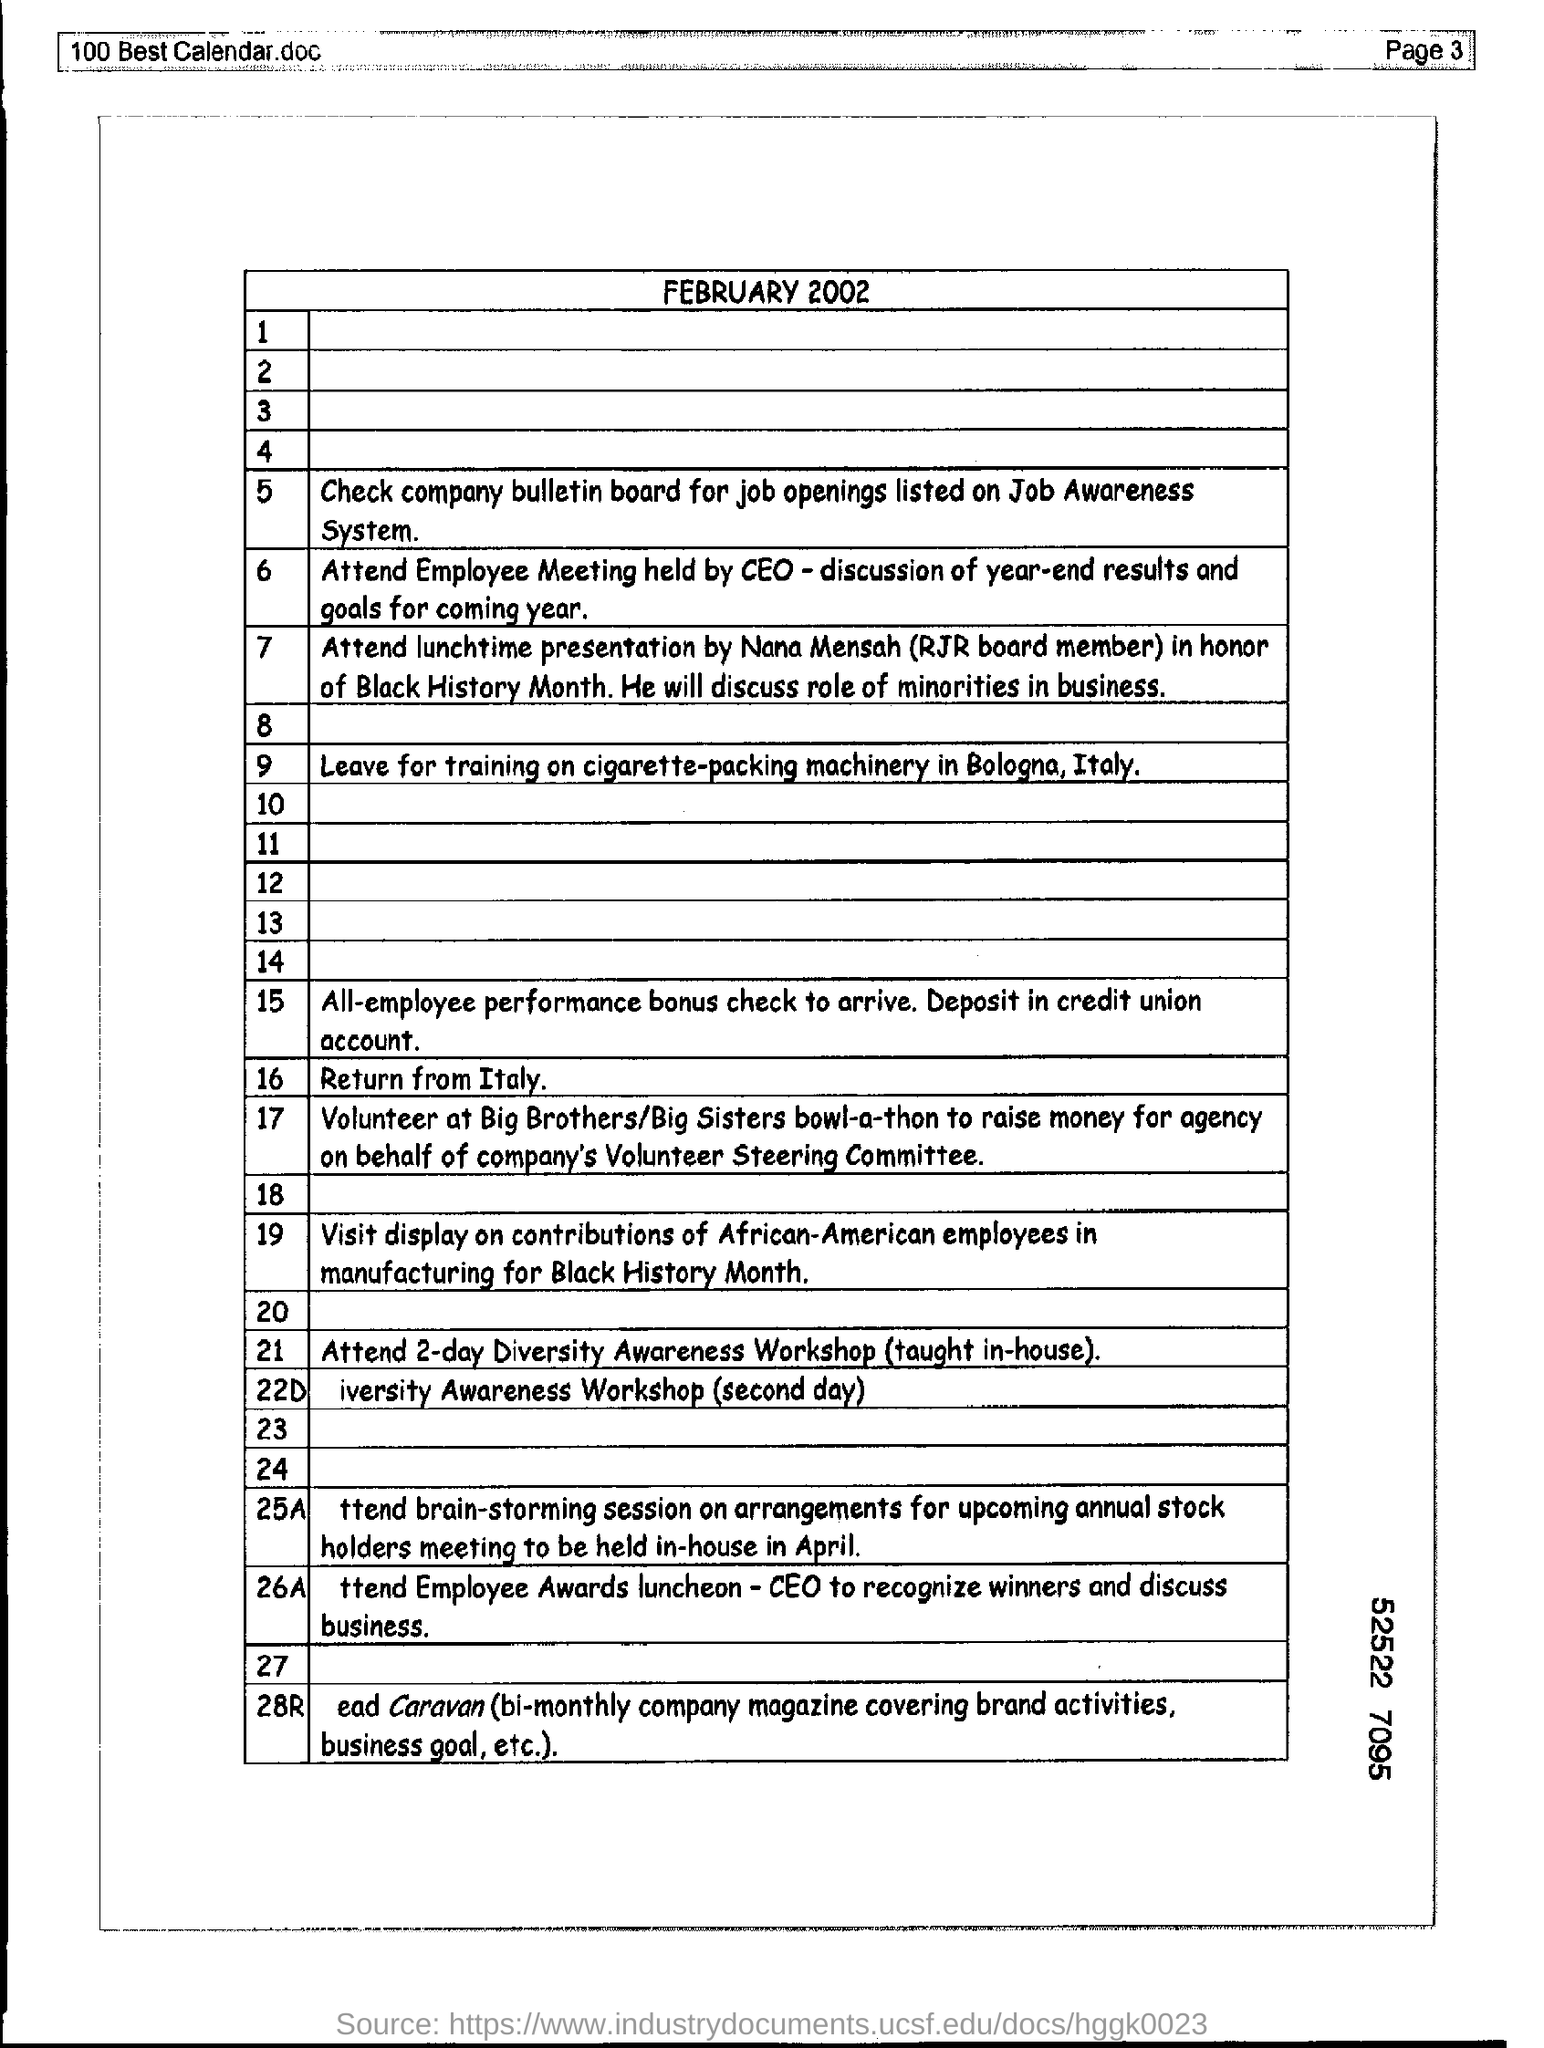Mention a couple of crucial points in this snapshot. Mention the page number at the top right corner of the page 3. 